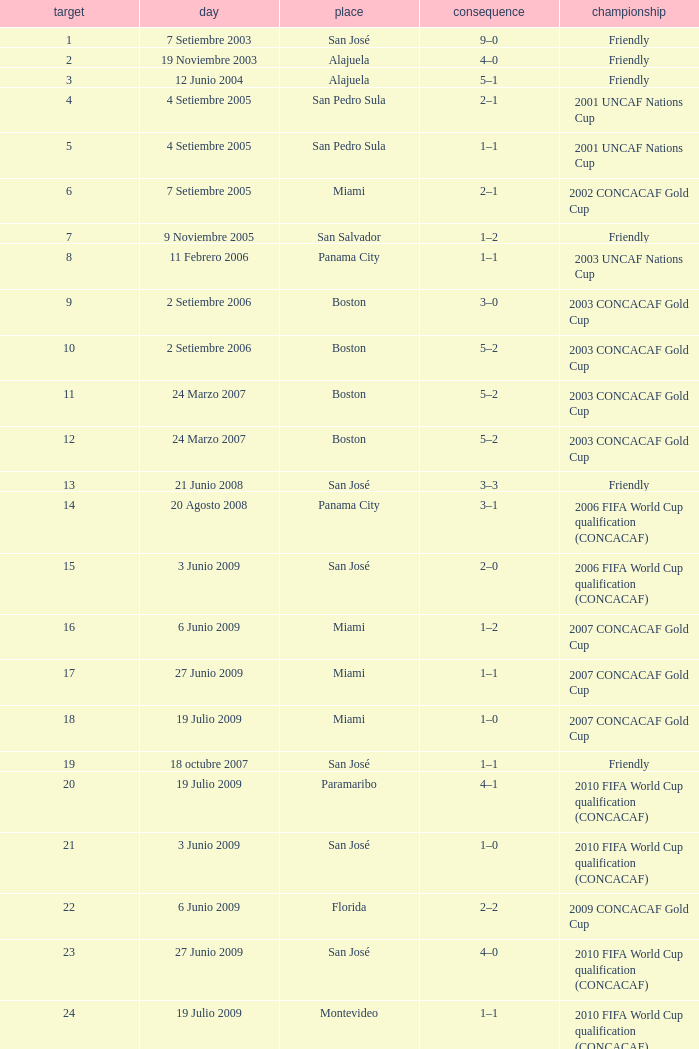How many goals were scored on 21 Junio 2008? 1.0. 